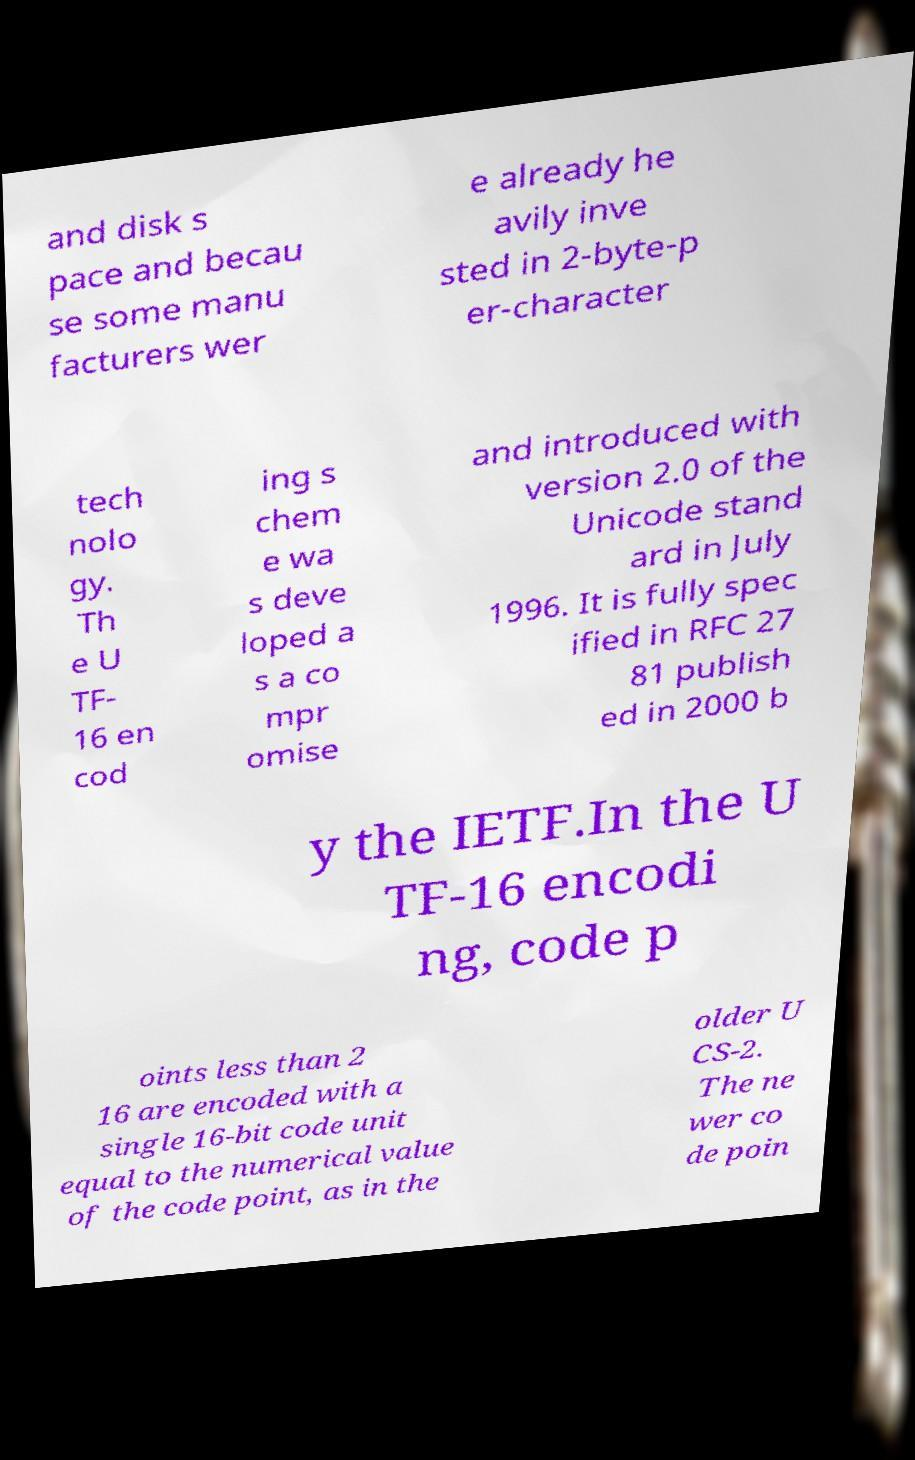There's text embedded in this image that I need extracted. Can you transcribe it verbatim? and disk s pace and becau se some manu facturers wer e already he avily inve sted in 2-byte-p er-character tech nolo gy. Th e U TF- 16 en cod ing s chem e wa s deve loped a s a co mpr omise and introduced with version 2.0 of the Unicode stand ard in July 1996. It is fully spec ified in RFC 27 81 publish ed in 2000 b y the IETF.In the U TF-16 encodi ng, code p oints less than 2 16 are encoded with a single 16-bit code unit equal to the numerical value of the code point, as in the older U CS-2. The ne wer co de poin 